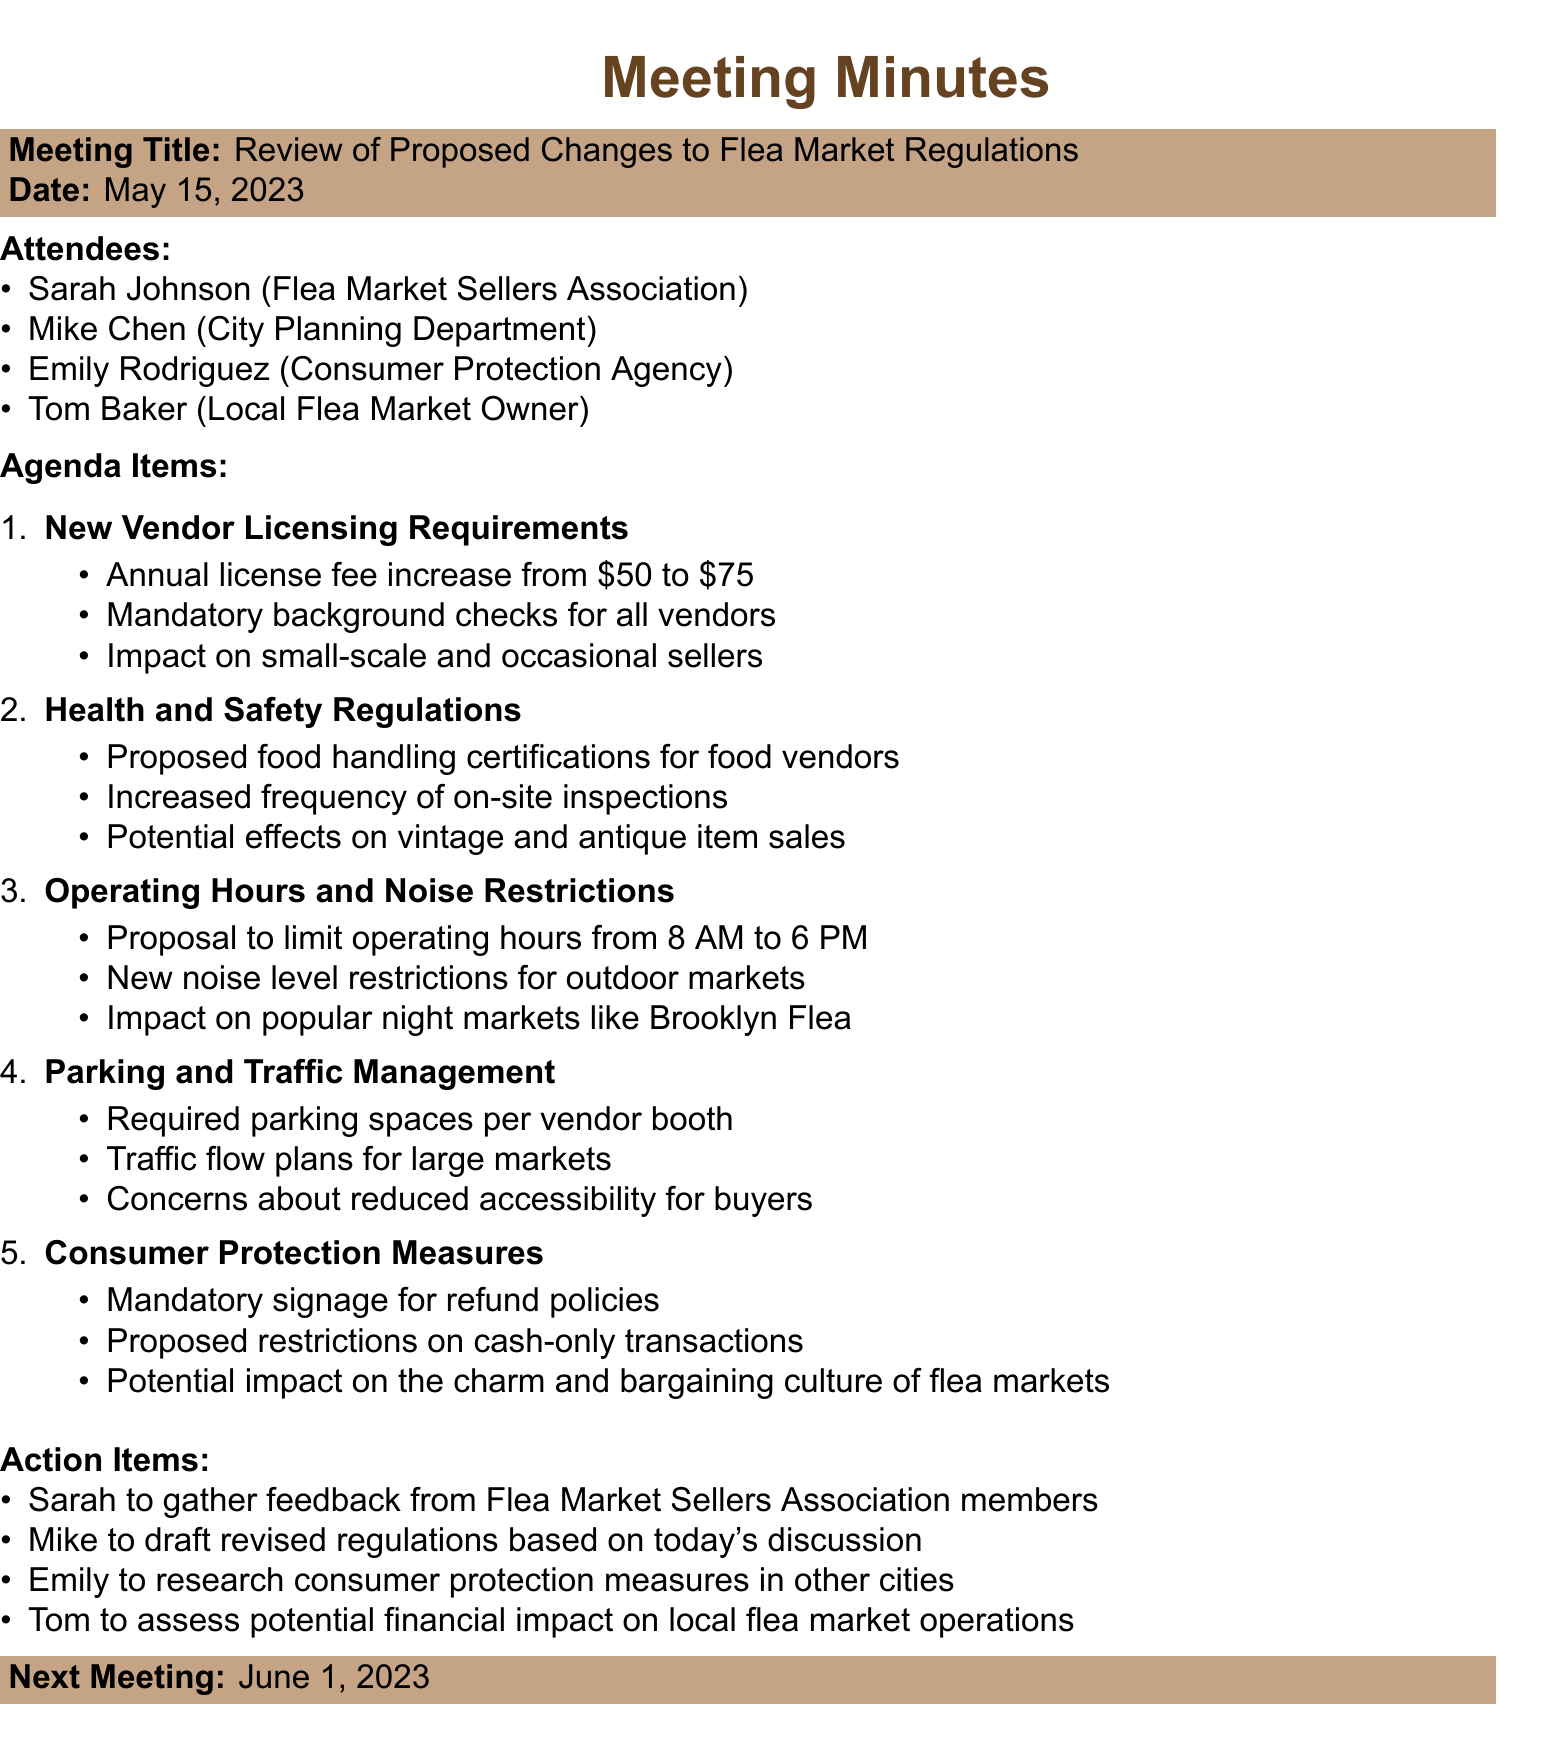What is the date of the meeting? The date of the meeting is specified at the beginning of the document.
Answer: May 15, 2023 Who is the local flea market owner present at the meeting? The attendees list includes the names of the individuals present.
Answer: Tom Baker What is the proposed annual license fee for vendors? The agenda item on New Vendor Licensing Requirements mentions the fee change.
Answer: $75 How often will on-site inspections be increased according to the Health and Safety Regulations? This is mentioned in the health and safety section of the agenda items.
Answer: Increased frequency What are the proposed new operating hours for flea markets? The Operating Hours and Noise Restrictions section outlines this proposal.
Answer: 8 AM to 6 PM What action item relates to gathering feedback from flea market sellers? The action items list specifies tasks assigned to attendees.
Answer: Sarah to gather feedback What is one potential effect of the new parking requirements? Concerns about parking accessibility for buyers are listed in the parking and traffic management section.
Answer: Reduced accessibility When is the next meeting scheduled? The next meeting date is provided at the end of the document.
Answer: June 1, 2023 How might the charm and bargaining culture of flea markets be affected? This reflects the potential impact outlined in the Consumer Protection Measures section.
Answer: Proposed restrictions on cash-only transactions 